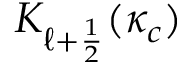Convert formula to latex. <formula><loc_0><loc_0><loc_500><loc_500>K _ { \ell + \frac { 1 } { 2 } } ( \kappa _ { c } )</formula> 